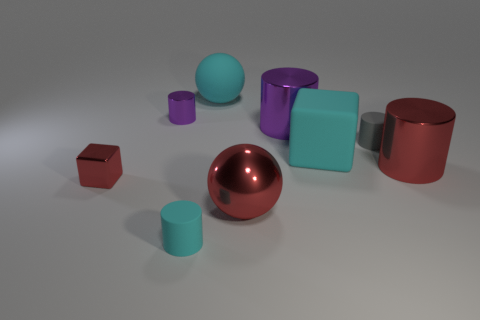There is a large cylinder that is the same color as the small block; what is it made of?
Provide a short and direct response. Metal. What size is the matte ball that is the same color as the large rubber cube?
Your answer should be compact. Large. What is the material of the gray object?
Your answer should be very brief. Rubber. Do the small purple cylinder and the cyan object that is in front of the shiny cube have the same material?
Your answer should be very brief. No. There is a tiny matte cylinder right of the cyan object that is right of the large cyan rubber ball; what is its color?
Ensure brevity in your answer.  Gray. There is a cyan matte object that is both in front of the tiny purple metallic cylinder and behind the large red ball; what size is it?
Provide a short and direct response. Large. What number of other things are there of the same shape as the small gray object?
Your answer should be compact. 4. There is a small purple object; is it the same shape as the large red thing on the left side of the gray rubber cylinder?
Your answer should be very brief. No. There is a cyan rubber sphere; how many cylinders are right of it?
Offer a terse response. 3. There is a large red metal thing that is left of the cyan rubber block; does it have the same shape as the tiny red thing?
Give a very brief answer. No. 